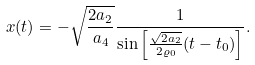<formula> <loc_0><loc_0><loc_500><loc_500>x ( t ) = - \sqrt { \frac { 2 a _ { 2 } } { a _ { 4 } } } \frac { 1 } { \sin \left [ \frac { \sqrt { 2 a _ { 2 } } } { 2 \varrho _ { 0 } } ( t - t _ { 0 } ) \right ] } .</formula> 